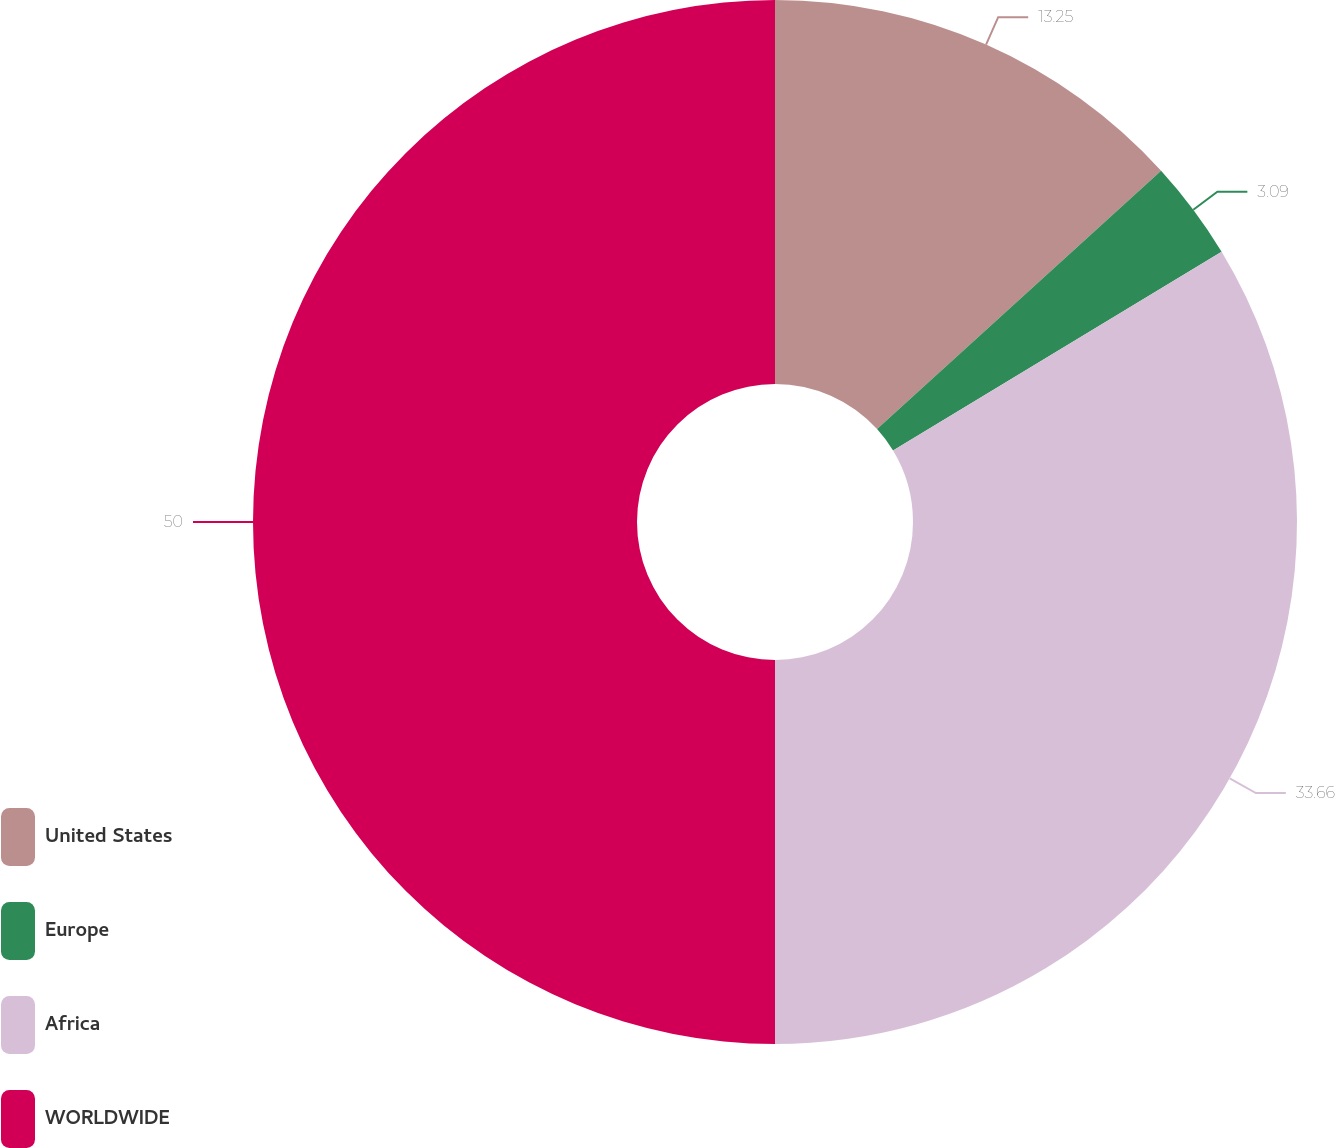Convert chart. <chart><loc_0><loc_0><loc_500><loc_500><pie_chart><fcel>United States<fcel>Europe<fcel>Africa<fcel>WORLDWIDE<nl><fcel>13.25%<fcel>3.09%<fcel>33.66%<fcel>50.0%<nl></chart> 